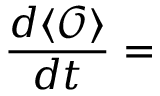Convert formula to latex. <formula><loc_0><loc_0><loc_500><loc_500>\frac { d \langle { \mathcal { O } } \rangle } { d t } =</formula> 